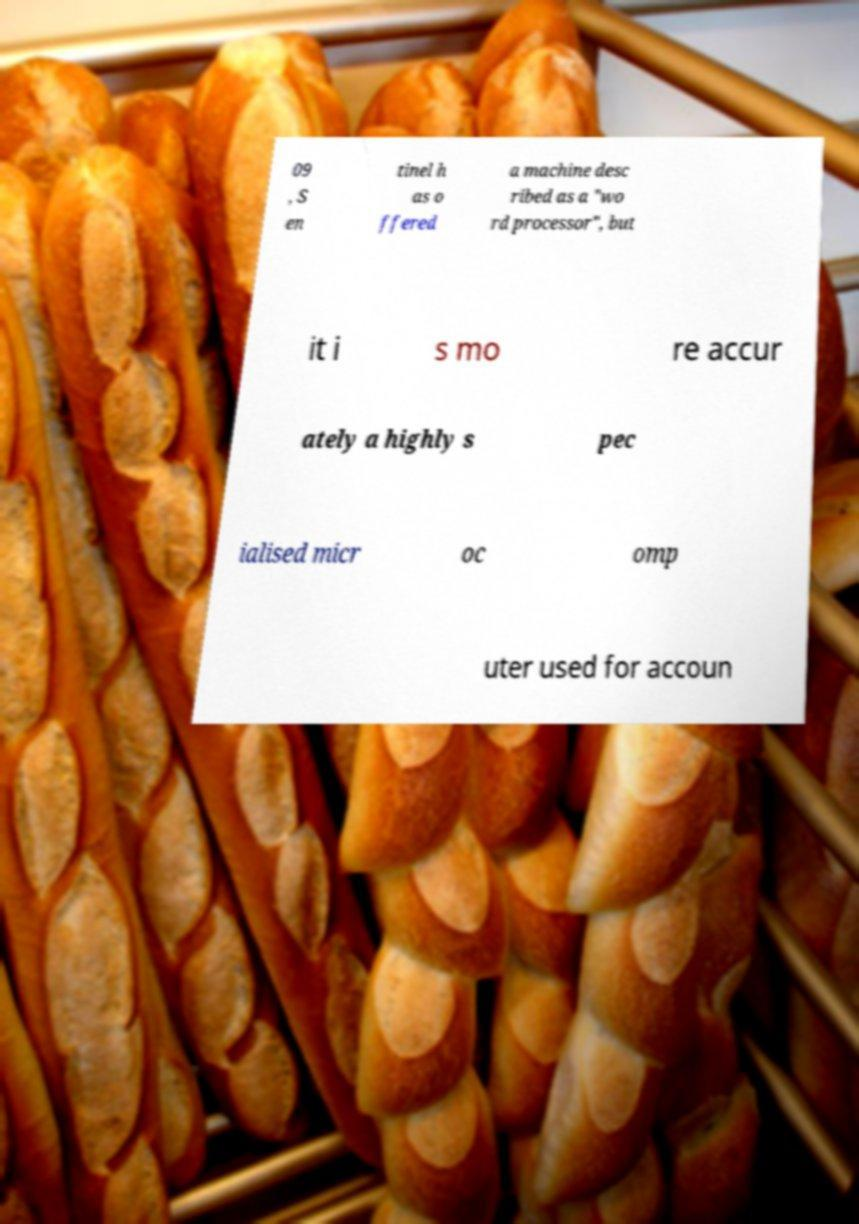Please identify and transcribe the text found in this image. 09 , S en tinel h as o ffered a machine desc ribed as a "wo rd processor", but it i s mo re accur ately a highly s pec ialised micr oc omp uter used for accoun 